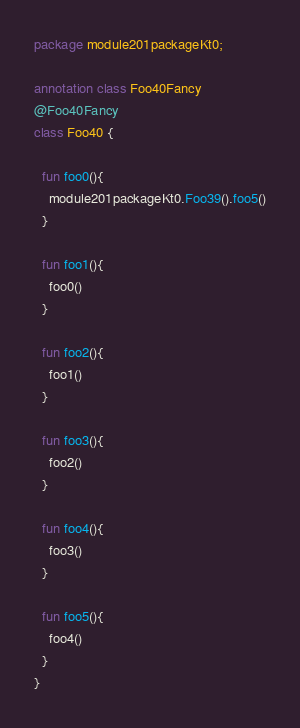Convert code to text. <code><loc_0><loc_0><loc_500><loc_500><_Kotlin_>package module201packageKt0;

annotation class Foo40Fancy
@Foo40Fancy
class Foo40 {

  fun foo0(){
    module201packageKt0.Foo39().foo5()
  }

  fun foo1(){
    foo0()
  }

  fun foo2(){
    foo1()
  }

  fun foo3(){
    foo2()
  }

  fun foo4(){
    foo3()
  }

  fun foo5(){
    foo4()
  }
}</code> 